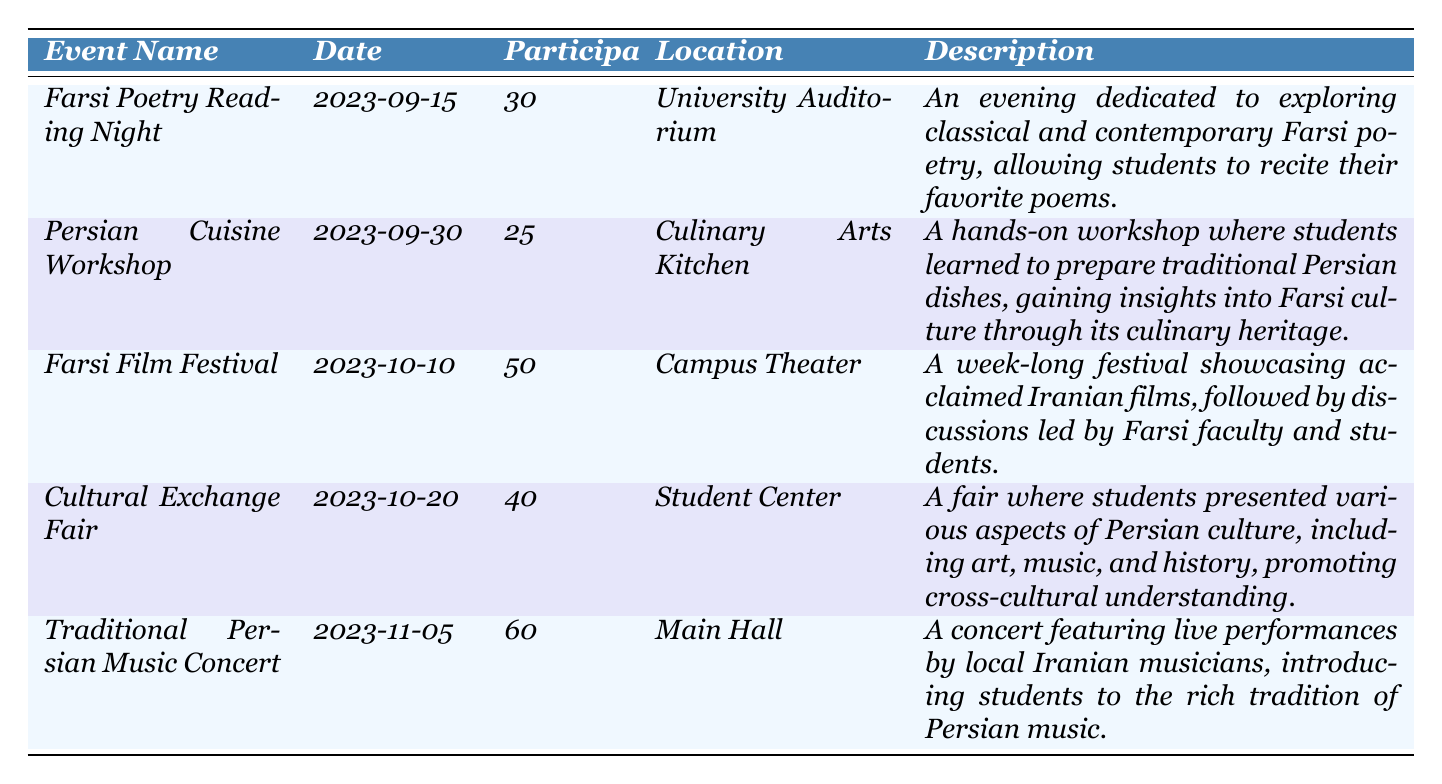What is the date of the Farsi Film Festival? The Farsi Film Festival is listed in the table, and the date next to it is 2023-10-10.
Answer: 2023-10-10 How many participants attended the Traditional Persian Music Concert? The table indicates that the Traditional Persian Music Concert had 60 participants as noted in the 'Participants' column for that event.
Answer: 60 What is the total number of participants for all events listed? To find the total number of participants, I add the numbers from each event: 30 (Farsi Poetry Reading Night) + 25 (Persian Cuisine Workshop) + 50 (Farsi Film Festival) + 40 (Cultural Exchange Fair) + 60 (Traditional Persian Music Concert) = 205.
Answer: 205 Was there any event with more than 50 participants? Looking through the 'Participants' column, I see that both the Farsi Film Festival (50 participants) and Traditional Persian Music Concert (60 participants) exceed 50 participants.
Answer: Yes Which event location had the least number of participants? By checking the 'Participants' column, the Persian Cuisine Workshop had the least with 25 participants compared to the others listed, which had more.
Answer: Culinary Arts Kitchen How does the number of participants in the Farsi Poetry Reading Night compare to the Cultural Exchange Fair? The Farsi Poetry Reading Night had 30 participants and the Cultural Exchange Fair had 40. Therefore, the Cultural Exchange Fair had more participants by 10.
Answer: The Cultural Exchange Fair had 10 more participants What is the average number of participants per event? To find the average, I sum the total participants (205) and divide by the number of events (5): 205 / 5 = 41.
Answer: 41 Is there an event that focuses on Farsi cuisine? The table indicates that the Persian Cuisine Workshop focuses specifically on Farsi cuisine, as described in its description.
Answer: Yes What percentage of the total participants attended the Traditional Persian Music Concert? The Traditional Persian Music Concert had 60 participants. To find the percentage: (60 / 205) × 100 = 29.27%, which rounds to 29%.
Answer: Approximately 29% How many events took place before October 10, 2023? Reviewing the dates, the Farsi Poetry Reading Night (2023-09-15) and the Persian Cuisine Workshop (2023-09-30) occurred before October 10, so there were two events.
Answer: 2 